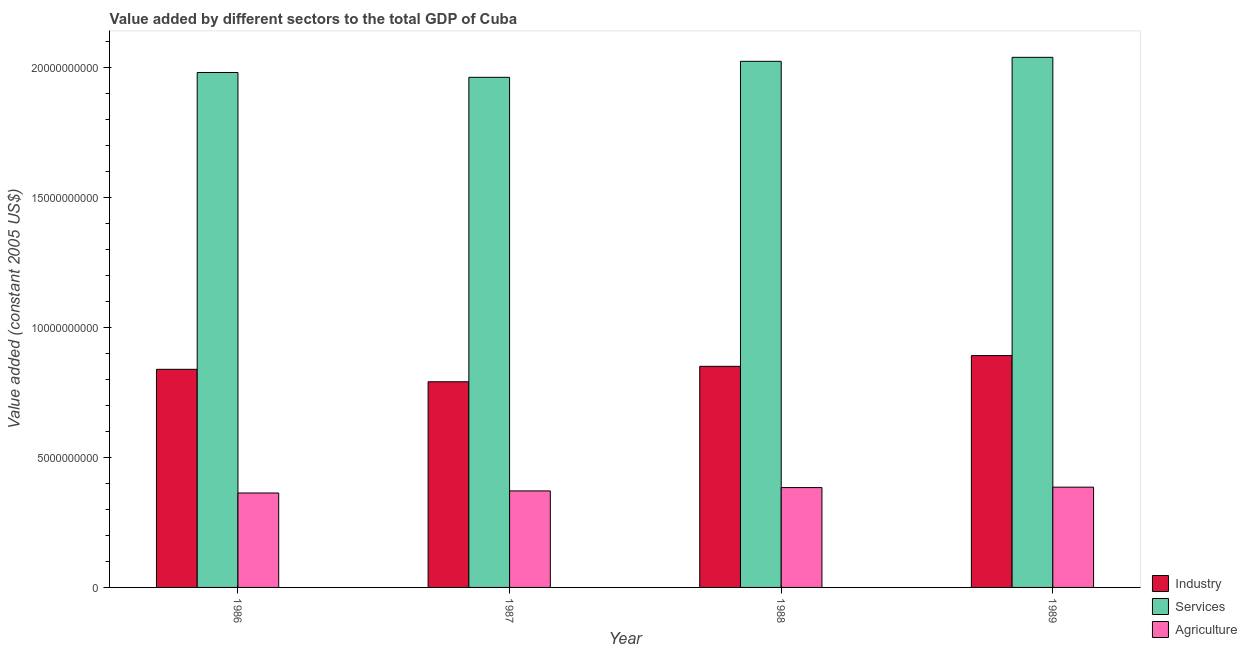How many different coloured bars are there?
Make the answer very short. 3. How many groups of bars are there?
Keep it short and to the point. 4. Are the number of bars on each tick of the X-axis equal?
Keep it short and to the point. Yes. In how many cases, is the number of bars for a given year not equal to the number of legend labels?
Offer a terse response. 0. What is the value added by industrial sector in 1987?
Keep it short and to the point. 7.91e+09. Across all years, what is the maximum value added by agricultural sector?
Provide a succinct answer. 3.85e+09. Across all years, what is the minimum value added by agricultural sector?
Provide a succinct answer. 3.63e+09. What is the total value added by services in the graph?
Offer a very short reply. 8.00e+1. What is the difference between the value added by services in 1987 and that in 1989?
Keep it short and to the point. -7.68e+08. What is the difference between the value added by services in 1988 and the value added by industrial sector in 1986?
Provide a short and direct response. 4.30e+08. What is the average value added by industrial sector per year?
Give a very brief answer. 8.43e+09. What is the ratio of the value added by agricultural sector in 1987 to that in 1989?
Your answer should be compact. 0.96. What is the difference between the highest and the second highest value added by services?
Provide a succinct answer. 1.53e+08. What is the difference between the highest and the lowest value added by agricultural sector?
Your answer should be very brief. 2.24e+08. In how many years, is the value added by industrial sector greater than the average value added by industrial sector taken over all years?
Offer a very short reply. 2. Is the sum of the value added by services in 1986 and 1989 greater than the maximum value added by industrial sector across all years?
Provide a short and direct response. Yes. What does the 2nd bar from the left in 1989 represents?
Provide a short and direct response. Services. What does the 3rd bar from the right in 1988 represents?
Make the answer very short. Industry. Does the graph contain any zero values?
Offer a terse response. No. How are the legend labels stacked?
Keep it short and to the point. Vertical. What is the title of the graph?
Your answer should be compact. Value added by different sectors to the total GDP of Cuba. What is the label or title of the Y-axis?
Provide a short and direct response. Value added (constant 2005 US$). What is the Value added (constant 2005 US$) of Industry in 1986?
Your answer should be compact. 8.39e+09. What is the Value added (constant 2005 US$) in Services in 1986?
Give a very brief answer. 1.98e+1. What is the Value added (constant 2005 US$) in Agriculture in 1986?
Offer a very short reply. 3.63e+09. What is the Value added (constant 2005 US$) in Industry in 1987?
Provide a succinct answer. 7.91e+09. What is the Value added (constant 2005 US$) of Services in 1987?
Your answer should be compact. 1.96e+1. What is the Value added (constant 2005 US$) in Agriculture in 1987?
Offer a terse response. 3.71e+09. What is the Value added (constant 2005 US$) of Industry in 1988?
Provide a short and direct response. 8.50e+09. What is the Value added (constant 2005 US$) of Services in 1988?
Your response must be concise. 2.02e+1. What is the Value added (constant 2005 US$) in Agriculture in 1988?
Give a very brief answer. 3.84e+09. What is the Value added (constant 2005 US$) in Industry in 1989?
Your response must be concise. 8.91e+09. What is the Value added (constant 2005 US$) in Services in 1989?
Keep it short and to the point. 2.04e+1. What is the Value added (constant 2005 US$) in Agriculture in 1989?
Offer a very short reply. 3.85e+09. Across all years, what is the maximum Value added (constant 2005 US$) in Industry?
Keep it short and to the point. 8.91e+09. Across all years, what is the maximum Value added (constant 2005 US$) in Services?
Keep it short and to the point. 2.04e+1. Across all years, what is the maximum Value added (constant 2005 US$) of Agriculture?
Your answer should be compact. 3.85e+09. Across all years, what is the minimum Value added (constant 2005 US$) in Industry?
Offer a terse response. 7.91e+09. Across all years, what is the minimum Value added (constant 2005 US$) in Services?
Provide a short and direct response. 1.96e+1. Across all years, what is the minimum Value added (constant 2005 US$) of Agriculture?
Your answer should be very brief. 3.63e+09. What is the total Value added (constant 2005 US$) of Industry in the graph?
Provide a succinct answer. 3.37e+1. What is the total Value added (constant 2005 US$) in Services in the graph?
Your answer should be compact. 8.00e+1. What is the total Value added (constant 2005 US$) of Agriculture in the graph?
Your answer should be very brief. 1.50e+1. What is the difference between the Value added (constant 2005 US$) of Industry in 1986 and that in 1987?
Offer a very short reply. 4.79e+08. What is the difference between the Value added (constant 2005 US$) in Services in 1986 and that in 1987?
Ensure brevity in your answer.  1.85e+08. What is the difference between the Value added (constant 2005 US$) of Agriculture in 1986 and that in 1987?
Offer a terse response. -7.95e+07. What is the difference between the Value added (constant 2005 US$) in Industry in 1986 and that in 1988?
Offer a very short reply. -1.14e+08. What is the difference between the Value added (constant 2005 US$) of Services in 1986 and that in 1988?
Give a very brief answer. -4.30e+08. What is the difference between the Value added (constant 2005 US$) of Agriculture in 1986 and that in 1988?
Your answer should be compact. -2.07e+08. What is the difference between the Value added (constant 2005 US$) of Industry in 1986 and that in 1989?
Provide a succinct answer. -5.28e+08. What is the difference between the Value added (constant 2005 US$) of Services in 1986 and that in 1989?
Give a very brief answer. -5.84e+08. What is the difference between the Value added (constant 2005 US$) of Agriculture in 1986 and that in 1989?
Keep it short and to the point. -2.24e+08. What is the difference between the Value added (constant 2005 US$) in Industry in 1987 and that in 1988?
Provide a short and direct response. -5.93e+08. What is the difference between the Value added (constant 2005 US$) in Services in 1987 and that in 1988?
Give a very brief answer. -6.15e+08. What is the difference between the Value added (constant 2005 US$) of Agriculture in 1987 and that in 1988?
Your response must be concise. -1.28e+08. What is the difference between the Value added (constant 2005 US$) of Industry in 1987 and that in 1989?
Offer a very short reply. -1.01e+09. What is the difference between the Value added (constant 2005 US$) in Services in 1987 and that in 1989?
Your answer should be very brief. -7.68e+08. What is the difference between the Value added (constant 2005 US$) in Agriculture in 1987 and that in 1989?
Provide a succinct answer. -1.44e+08. What is the difference between the Value added (constant 2005 US$) in Industry in 1988 and that in 1989?
Provide a short and direct response. -4.14e+08. What is the difference between the Value added (constant 2005 US$) of Services in 1988 and that in 1989?
Give a very brief answer. -1.53e+08. What is the difference between the Value added (constant 2005 US$) of Agriculture in 1988 and that in 1989?
Offer a terse response. -1.64e+07. What is the difference between the Value added (constant 2005 US$) of Industry in 1986 and the Value added (constant 2005 US$) of Services in 1987?
Your response must be concise. -1.12e+1. What is the difference between the Value added (constant 2005 US$) in Industry in 1986 and the Value added (constant 2005 US$) in Agriculture in 1987?
Provide a succinct answer. 4.67e+09. What is the difference between the Value added (constant 2005 US$) of Services in 1986 and the Value added (constant 2005 US$) of Agriculture in 1987?
Provide a short and direct response. 1.61e+1. What is the difference between the Value added (constant 2005 US$) in Industry in 1986 and the Value added (constant 2005 US$) in Services in 1988?
Your answer should be compact. -1.18e+1. What is the difference between the Value added (constant 2005 US$) in Industry in 1986 and the Value added (constant 2005 US$) in Agriculture in 1988?
Make the answer very short. 4.55e+09. What is the difference between the Value added (constant 2005 US$) in Services in 1986 and the Value added (constant 2005 US$) in Agriculture in 1988?
Your answer should be very brief. 1.60e+1. What is the difference between the Value added (constant 2005 US$) of Industry in 1986 and the Value added (constant 2005 US$) of Services in 1989?
Your answer should be compact. -1.20e+1. What is the difference between the Value added (constant 2005 US$) in Industry in 1986 and the Value added (constant 2005 US$) in Agriculture in 1989?
Your answer should be very brief. 4.53e+09. What is the difference between the Value added (constant 2005 US$) in Services in 1986 and the Value added (constant 2005 US$) in Agriculture in 1989?
Offer a terse response. 1.59e+1. What is the difference between the Value added (constant 2005 US$) in Industry in 1987 and the Value added (constant 2005 US$) in Services in 1988?
Offer a terse response. -1.23e+1. What is the difference between the Value added (constant 2005 US$) in Industry in 1987 and the Value added (constant 2005 US$) in Agriculture in 1988?
Keep it short and to the point. 4.07e+09. What is the difference between the Value added (constant 2005 US$) of Services in 1987 and the Value added (constant 2005 US$) of Agriculture in 1988?
Provide a short and direct response. 1.58e+1. What is the difference between the Value added (constant 2005 US$) of Industry in 1987 and the Value added (constant 2005 US$) of Services in 1989?
Provide a succinct answer. -1.25e+1. What is the difference between the Value added (constant 2005 US$) in Industry in 1987 and the Value added (constant 2005 US$) in Agriculture in 1989?
Offer a very short reply. 4.05e+09. What is the difference between the Value added (constant 2005 US$) in Services in 1987 and the Value added (constant 2005 US$) in Agriculture in 1989?
Your answer should be compact. 1.58e+1. What is the difference between the Value added (constant 2005 US$) of Industry in 1988 and the Value added (constant 2005 US$) of Services in 1989?
Your answer should be very brief. -1.19e+1. What is the difference between the Value added (constant 2005 US$) of Industry in 1988 and the Value added (constant 2005 US$) of Agriculture in 1989?
Make the answer very short. 4.64e+09. What is the difference between the Value added (constant 2005 US$) of Services in 1988 and the Value added (constant 2005 US$) of Agriculture in 1989?
Give a very brief answer. 1.64e+1. What is the average Value added (constant 2005 US$) of Industry per year?
Offer a very short reply. 8.43e+09. What is the average Value added (constant 2005 US$) in Services per year?
Offer a very short reply. 2.00e+1. What is the average Value added (constant 2005 US$) in Agriculture per year?
Offer a terse response. 3.76e+09. In the year 1986, what is the difference between the Value added (constant 2005 US$) of Industry and Value added (constant 2005 US$) of Services?
Your answer should be compact. -1.14e+1. In the year 1986, what is the difference between the Value added (constant 2005 US$) in Industry and Value added (constant 2005 US$) in Agriculture?
Provide a succinct answer. 4.75e+09. In the year 1986, what is the difference between the Value added (constant 2005 US$) in Services and Value added (constant 2005 US$) in Agriculture?
Give a very brief answer. 1.62e+1. In the year 1987, what is the difference between the Value added (constant 2005 US$) of Industry and Value added (constant 2005 US$) of Services?
Provide a succinct answer. -1.17e+1. In the year 1987, what is the difference between the Value added (constant 2005 US$) of Industry and Value added (constant 2005 US$) of Agriculture?
Keep it short and to the point. 4.20e+09. In the year 1987, what is the difference between the Value added (constant 2005 US$) of Services and Value added (constant 2005 US$) of Agriculture?
Provide a short and direct response. 1.59e+1. In the year 1988, what is the difference between the Value added (constant 2005 US$) of Industry and Value added (constant 2005 US$) of Services?
Give a very brief answer. -1.17e+1. In the year 1988, what is the difference between the Value added (constant 2005 US$) in Industry and Value added (constant 2005 US$) in Agriculture?
Provide a succinct answer. 4.66e+09. In the year 1988, what is the difference between the Value added (constant 2005 US$) in Services and Value added (constant 2005 US$) in Agriculture?
Give a very brief answer. 1.64e+1. In the year 1989, what is the difference between the Value added (constant 2005 US$) of Industry and Value added (constant 2005 US$) of Services?
Make the answer very short. -1.15e+1. In the year 1989, what is the difference between the Value added (constant 2005 US$) of Industry and Value added (constant 2005 US$) of Agriculture?
Make the answer very short. 5.06e+09. In the year 1989, what is the difference between the Value added (constant 2005 US$) in Services and Value added (constant 2005 US$) in Agriculture?
Your answer should be very brief. 1.65e+1. What is the ratio of the Value added (constant 2005 US$) in Industry in 1986 to that in 1987?
Make the answer very short. 1.06. What is the ratio of the Value added (constant 2005 US$) of Services in 1986 to that in 1987?
Ensure brevity in your answer.  1.01. What is the ratio of the Value added (constant 2005 US$) in Agriculture in 1986 to that in 1987?
Make the answer very short. 0.98. What is the ratio of the Value added (constant 2005 US$) in Industry in 1986 to that in 1988?
Your response must be concise. 0.99. What is the ratio of the Value added (constant 2005 US$) in Services in 1986 to that in 1988?
Provide a short and direct response. 0.98. What is the ratio of the Value added (constant 2005 US$) in Agriculture in 1986 to that in 1988?
Provide a short and direct response. 0.95. What is the ratio of the Value added (constant 2005 US$) in Industry in 1986 to that in 1989?
Give a very brief answer. 0.94. What is the ratio of the Value added (constant 2005 US$) of Services in 1986 to that in 1989?
Give a very brief answer. 0.97. What is the ratio of the Value added (constant 2005 US$) in Agriculture in 1986 to that in 1989?
Keep it short and to the point. 0.94. What is the ratio of the Value added (constant 2005 US$) of Industry in 1987 to that in 1988?
Your answer should be very brief. 0.93. What is the ratio of the Value added (constant 2005 US$) of Services in 1987 to that in 1988?
Ensure brevity in your answer.  0.97. What is the ratio of the Value added (constant 2005 US$) in Agriculture in 1987 to that in 1988?
Keep it short and to the point. 0.97. What is the ratio of the Value added (constant 2005 US$) in Industry in 1987 to that in 1989?
Make the answer very short. 0.89. What is the ratio of the Value added (constant 2005 US$) of Services in 1987 to that in 1989?
Provide a succinct answer. 0.96. What is the ratio of the Value added (constant 2005 US$) in Agriculture in 1987 to that in 1989?
Provide a succinct answer. 0.96. What is the ratio of the Value added (constant 2005 US$) in Industry in 1988 to that in 1989?
Offer a terse response. 0.95. What is the difference between the highest and the second highest Value added (constant 2005 US$) in Industry?
Your response must be concise. 4.14e+08. What is the difference between the highest and the second highest Value added (constant 2005 US$) of Services?
Make the answer very short. 1.53e+08. What is the difference between the highest and the second highest Value added (constant 2005 US$) of Agriculture?
Provide a succinct answer. 1.64e+07. What is the difference between the highest and the lowest Value added (constant 2005 US$) in Industry?
Offer a terse response. 1.01e+09. What is the difference between the highest and the lowest Value added (constant 2005 US$) in Services?
Ensure brevity in your answer.  7.68e+08. What is the difference between the highest and the lowest Value added (constant 2005 US$) in Agriculture?
Offer a terse response. 2.24e+08. 